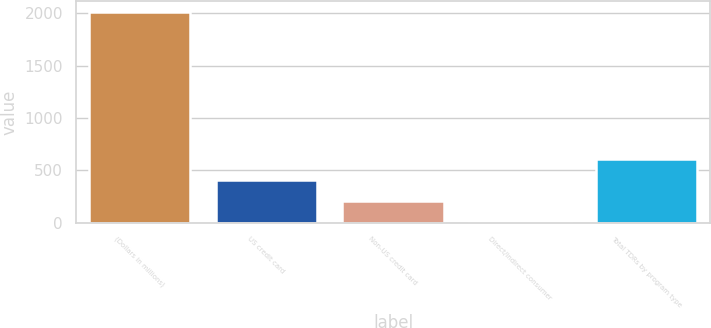<chart> <loc_0><loc_0><loc_500><loc_500><bar_chart><fcel>(Dollars in millions)<fcel>US credit card<fcel>Non-US credit card<fcel>Direct/Indirect consumer<fcel>Total TDRs by program type<nl><fcel>2016<fcel>404.8<fcel>203.4<fcel>2<fcel>606.2<nl></chart> 